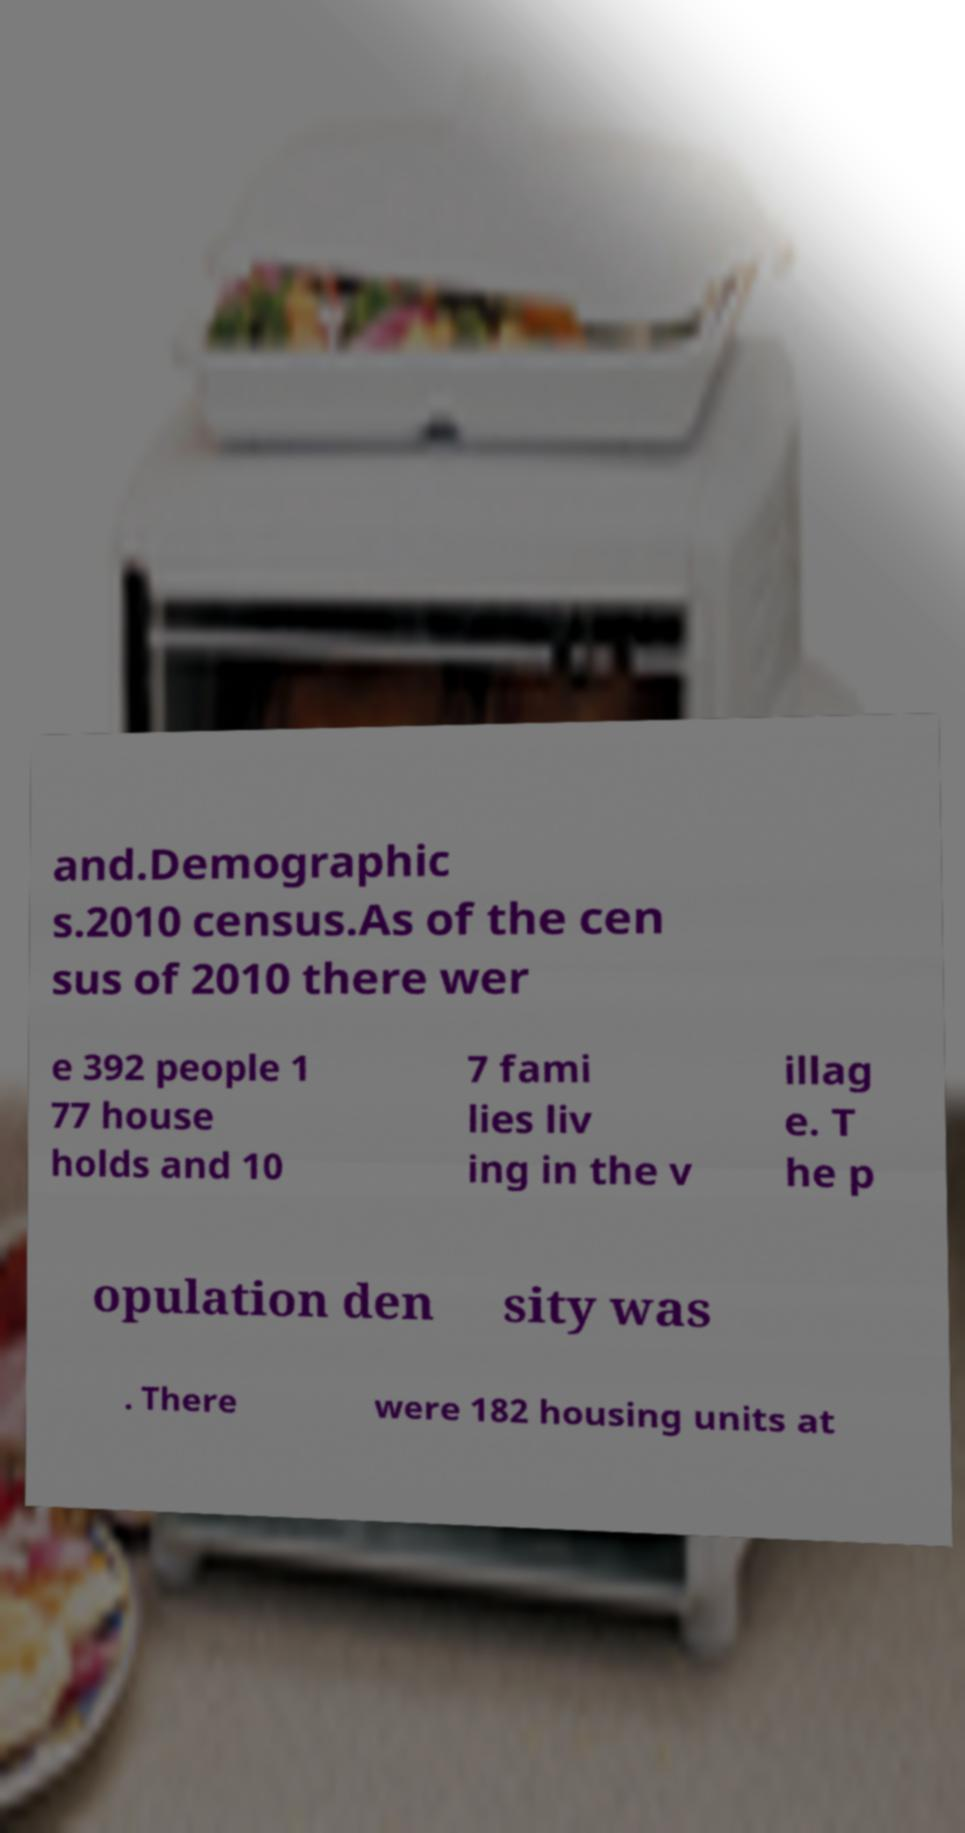Please identify and transcribe the text found in this image. and.Demographic s.2010 census.As of the cen sus of 2010 there wer e 392 people 1 77 house holds and 10 7 fami lies liv ing in the v illag e. T he p opulation den sity was . There were 182 housing units at 